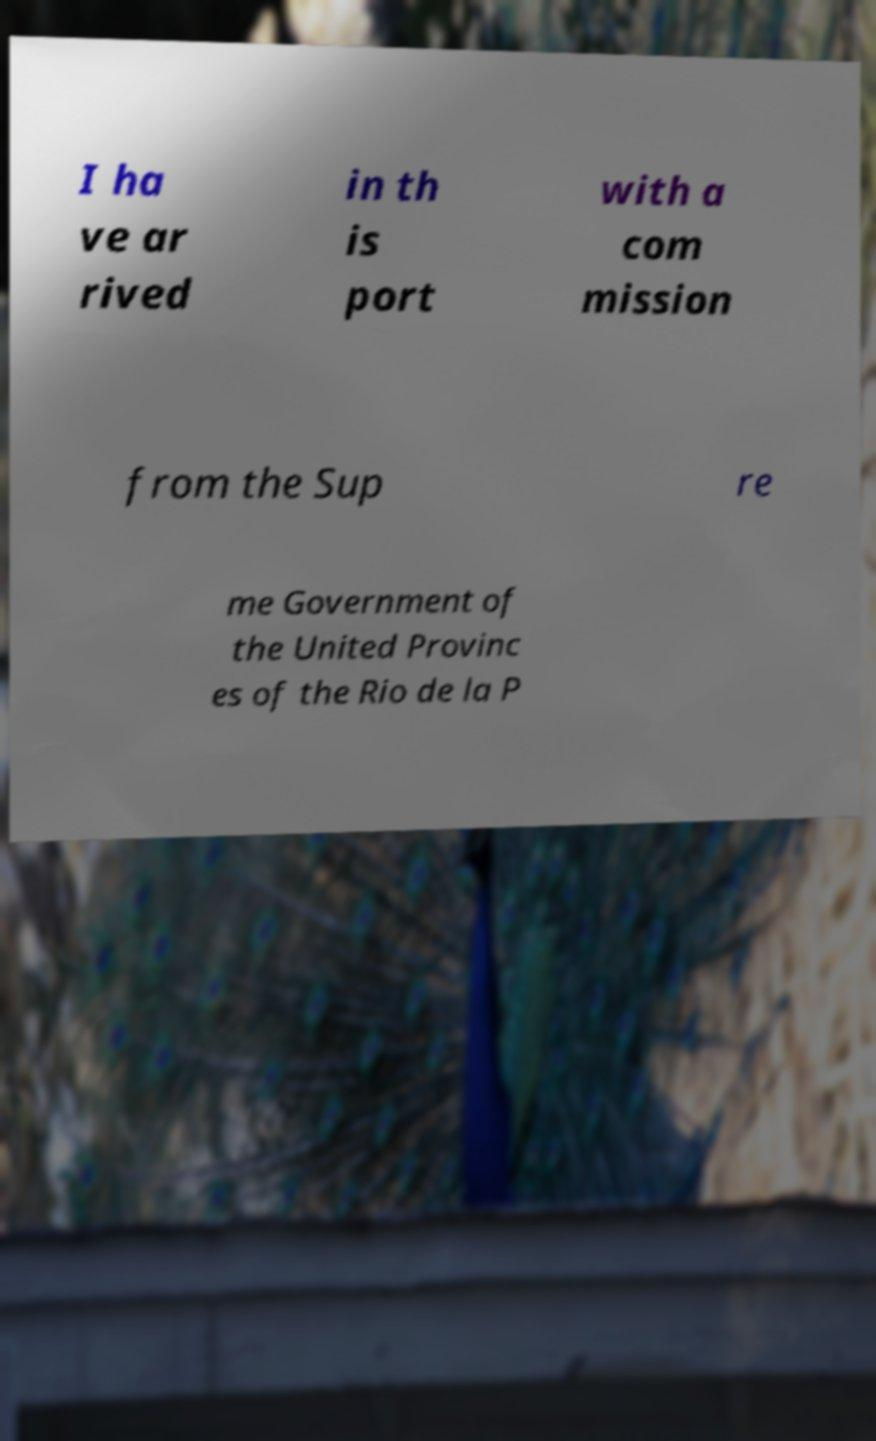There's text embedded in this image that I need extracted. Can you transcribe it verbatim? I ha ve ar rived in th is port with a com mission from the Sup re me Government of the United Provinc es of the Rio de la P 